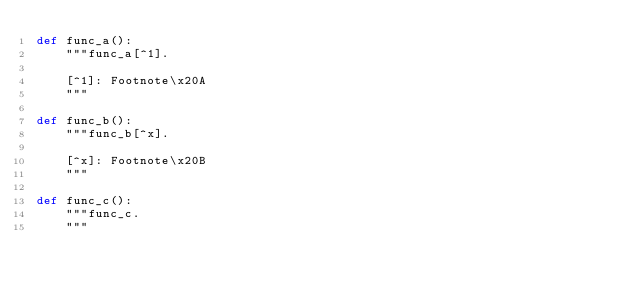<code> <loc_0><loc_0><loc_500><loc_500><_Python_>def func_a():
    """func_a[^1].

    [^1]: Footnote\x20A
    """

def func_b():
    """func_b[^x].

    [^x]: Footnote\x20B
    """

def func_c():
    """func_c.
    """
</code> 